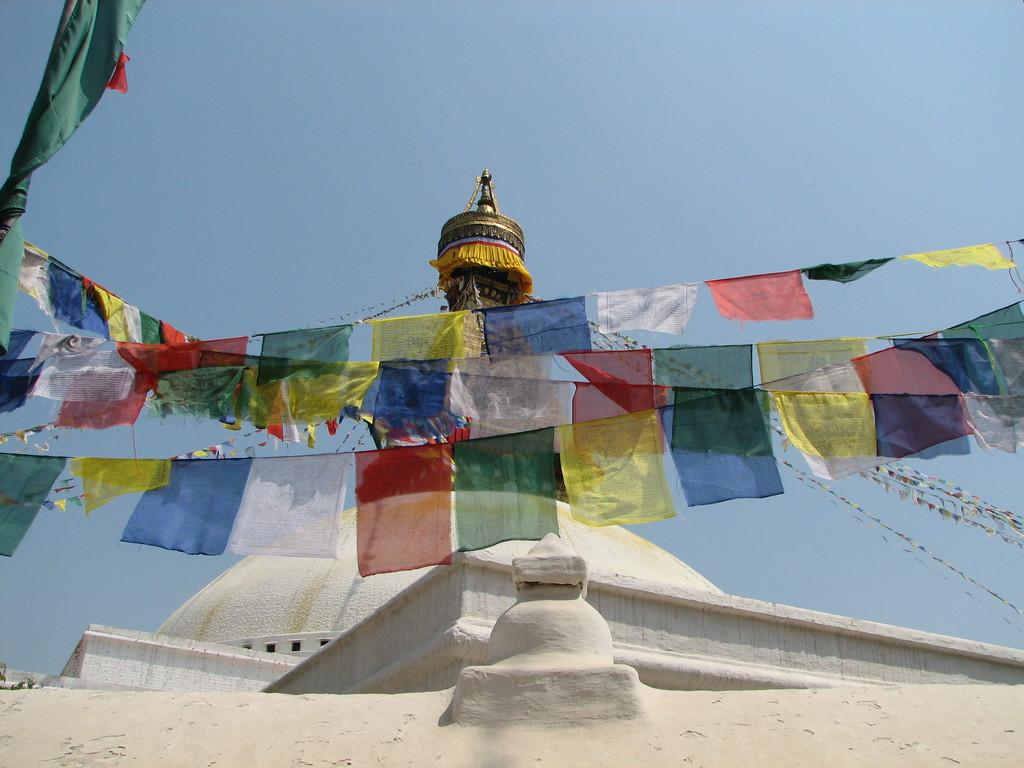What is the main structure visible in the image? There is a white tomb in the image. Are there any additional decorations or features on the tomb? Yes, there are colorful flags attached to the tomb. How many passengers can be seen sitting on the stone in the image? There are no passengers or stones present in the image; it features a white tomb with colorful flags attached to it. What type of creature has a fang that can be seen in the image? There is no creature with a fang present in the image. 